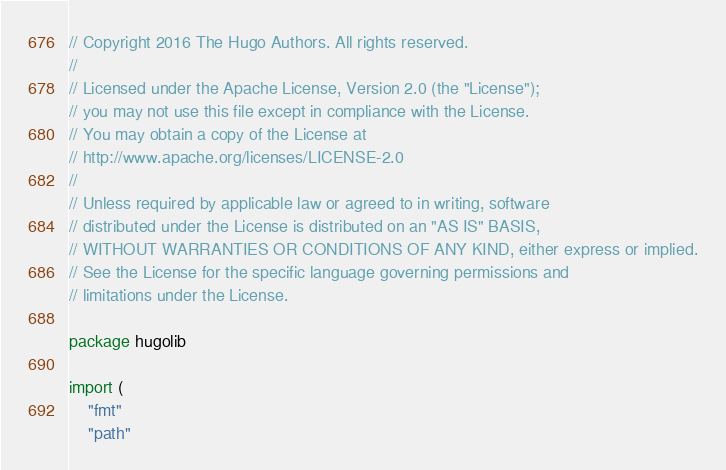Convert code to text. <code><loc_0><loc_0><loc_500><loc_500><_Go_>// Copyright 2016 The Hugo Authors. All rights reserved.
//
// Licensed under the Apache License, Version 2.0 (the "License");
// you may not use this file except in compliance with the License.
// You may obtain a copy of the License at
// http://www.apache.org/licenses/LICENSE-2.0
//
// Unless required by applicable law or agreed to in writing, software
// distributed under the License is distributed on an "AS IS" BASIS,
// WITHOUT WARRANTIES OR CONDITIONS OF ANY KIND, either express or implied.
// See the License for the specific language governing permissions and
// limitations under the License.

package hugolib

import (
	"fmt"
	"path"</code> 